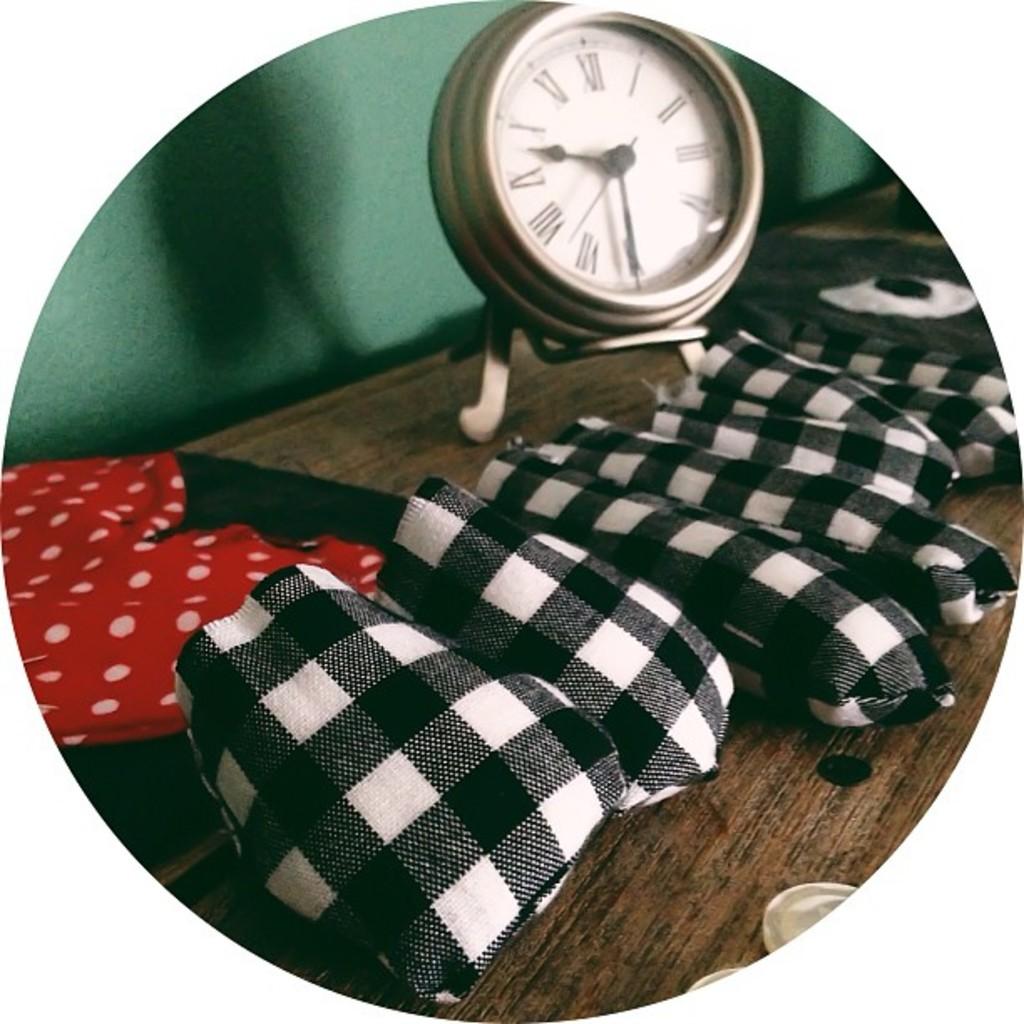What roman numerals represent 12:00?
Keep it short and to the point. Xii. 